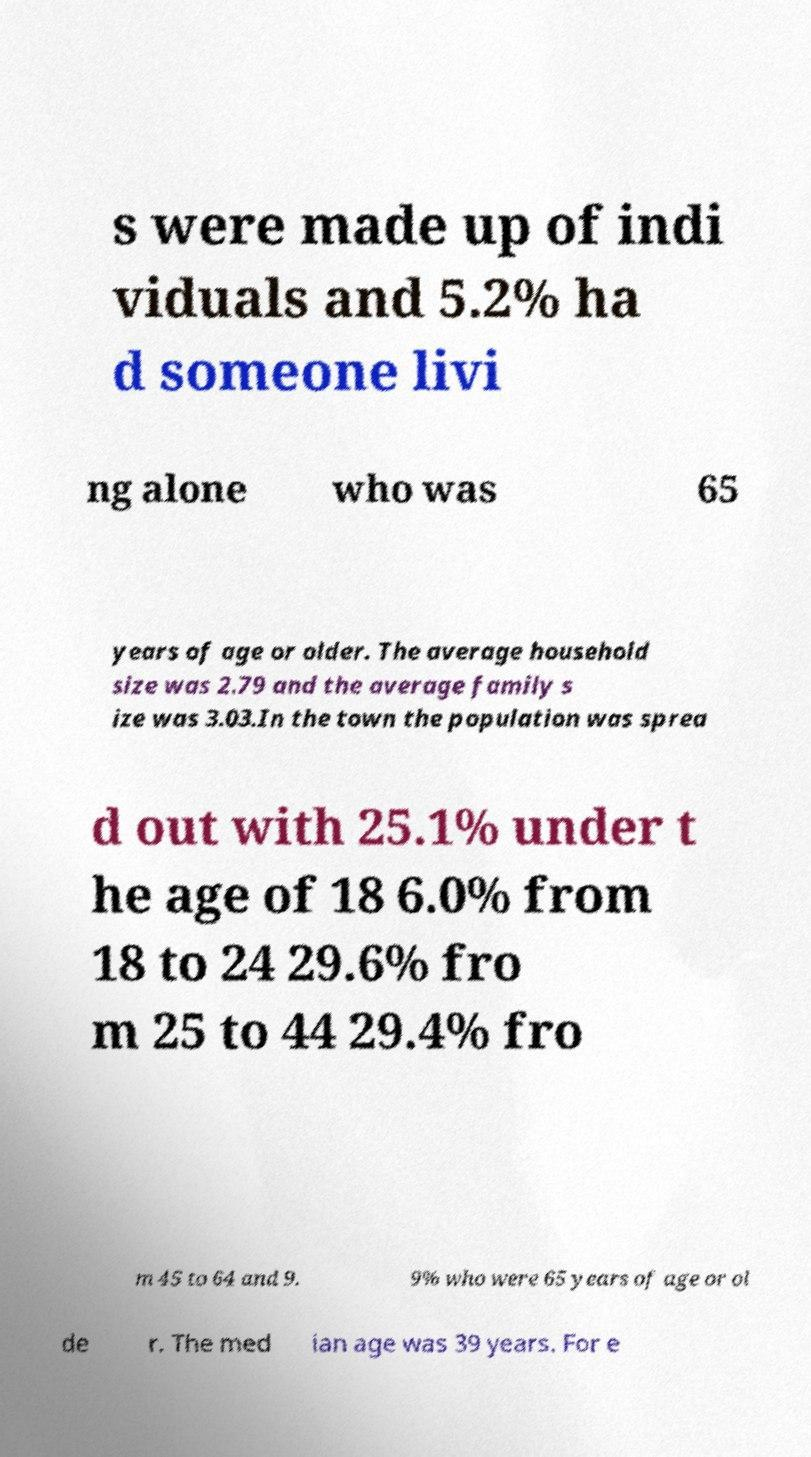For documentation purposes, I need the text within this image transcribed. Could you provide that? s were made up of indi viduals and 5.2% ha d someone livi ng alone who was 65 years of age or older. The average household size was 2.79 and the average family s ize was 3.03.In the town the population was sprea d out with 25.1% under t he age of 18 6.0% from 18 to 24 29.6% fro m 25 to 44 29.4% fro m 45 to 64 and 9. 9% who were 65 years of age or ol de r. The med ian age was 39 years. For e 